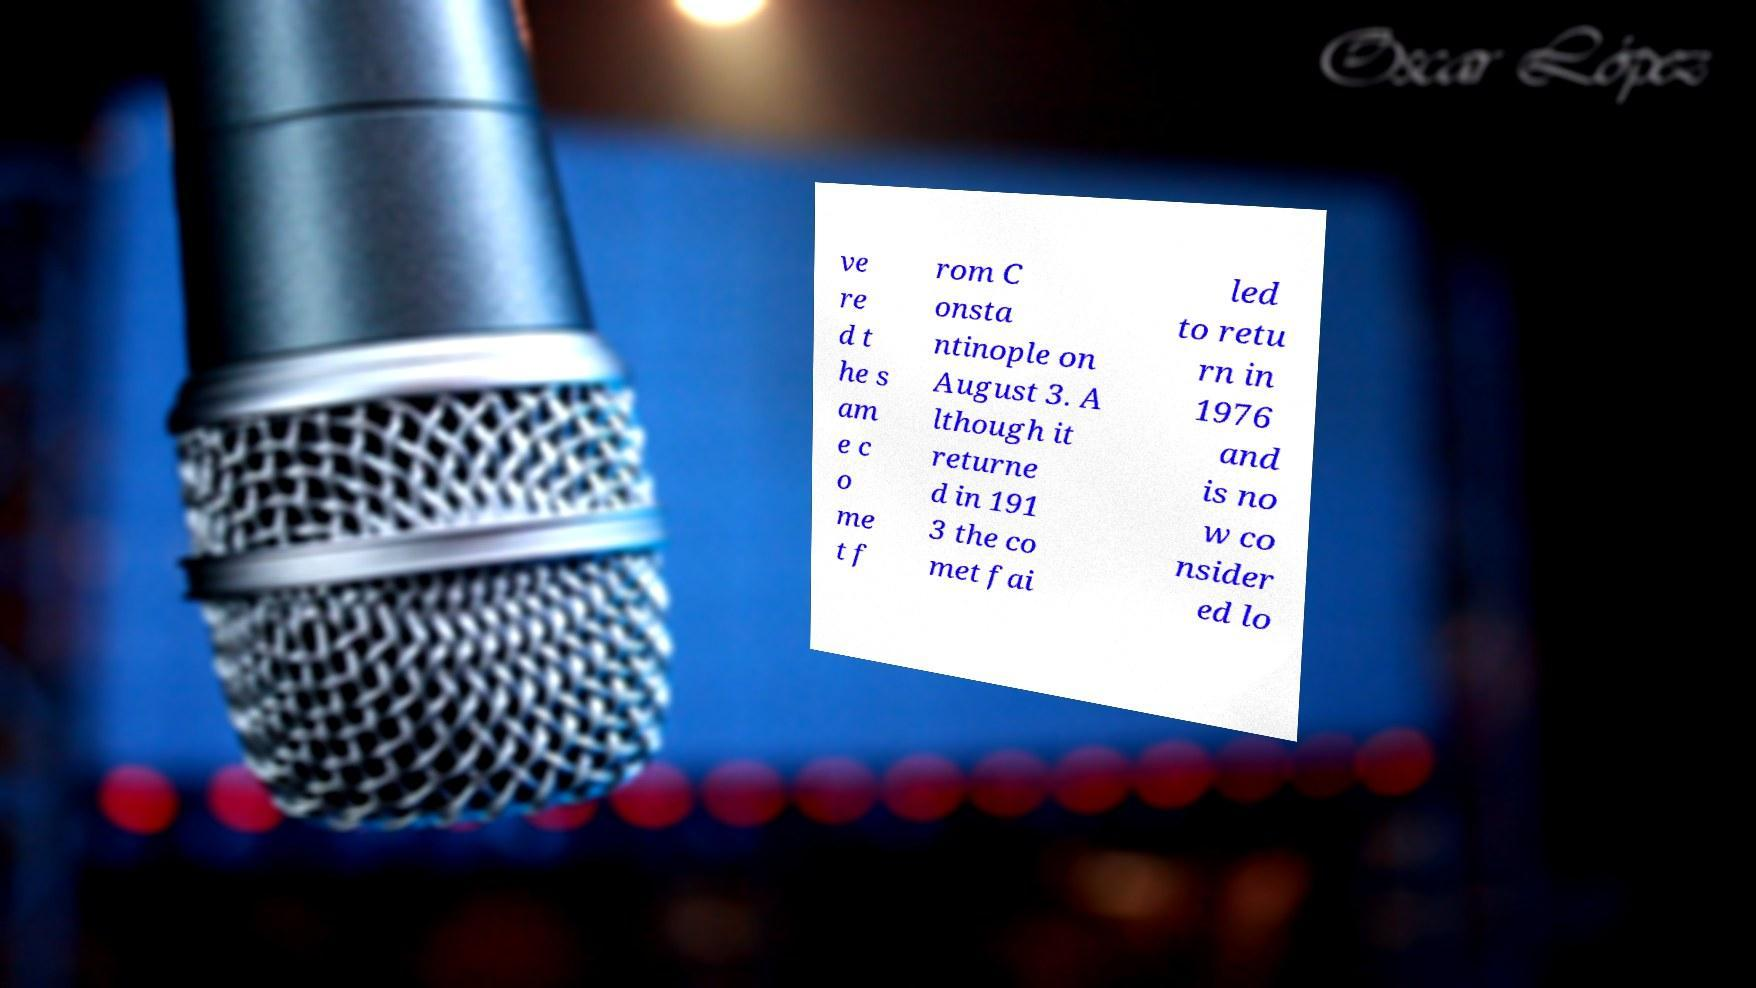Please read and relay the text visible in this image. What does it say? ve re d t he s am e c o me t f rom C onsta ntinople on August 3. A lthough it returne d in 191 3 the co met fai led to retu rn in 1976 and is no w co nsider ed lo 